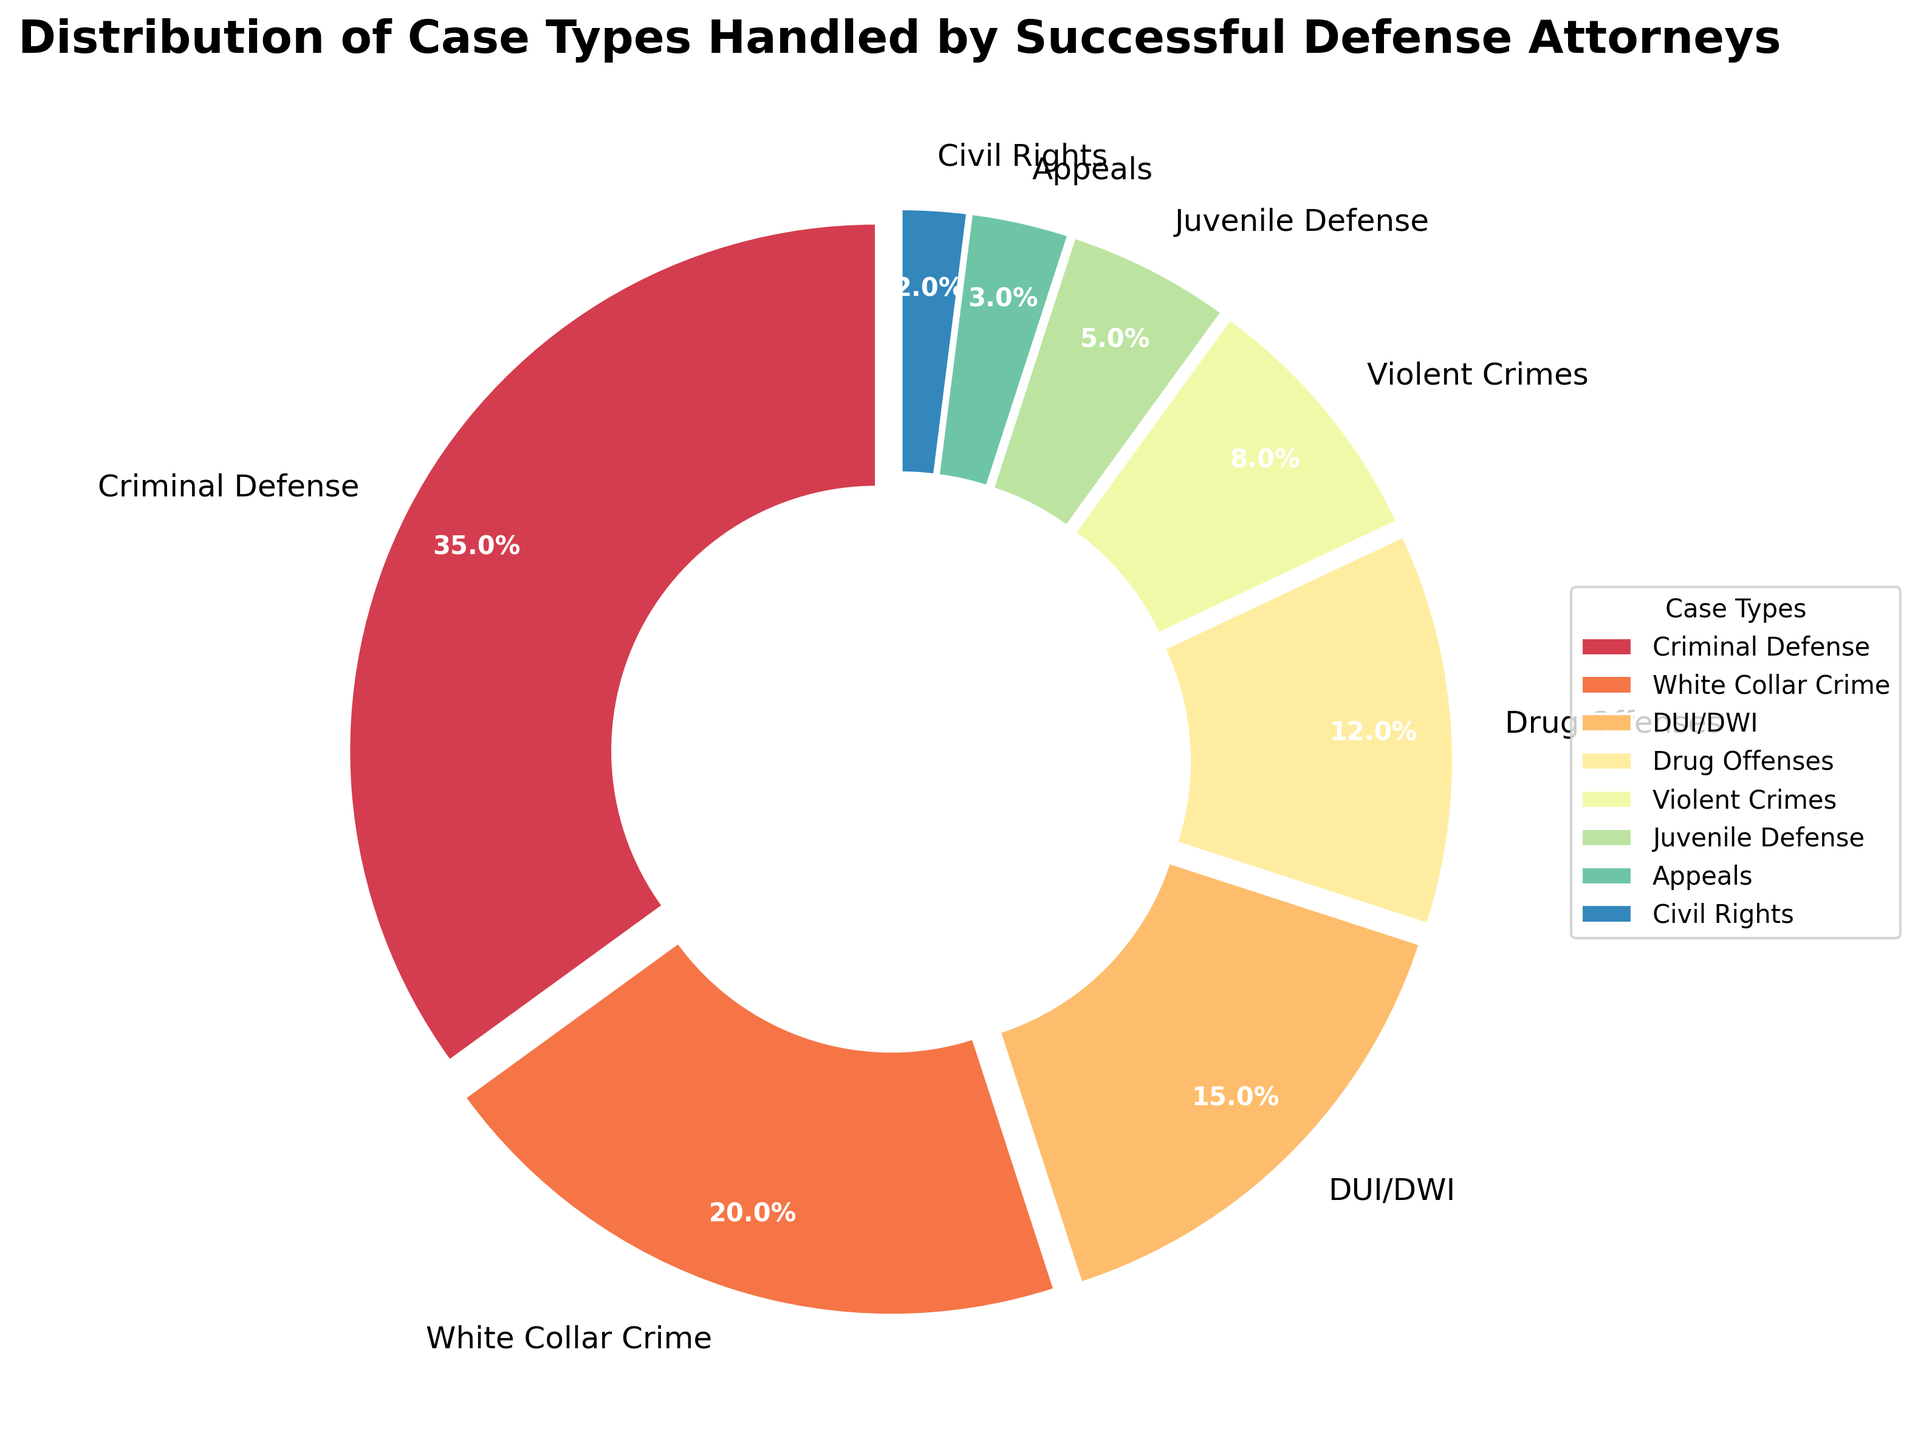Which case type is handled the most by successful defense attorneys? Observing the pie chart, Criminal Defense has the largest slice in the distribution, making it the most handled case type.
Answer: Criminal Defense Which case type is handled the least by successful defense attorneys? The smallest slice in the pie chart corresponds to Civil Rights, indicating it is the least handled case type.
Answer: Civil Rights How many percentage points more are Criminal Defense cases than White Collar Crime cases? Criminal Defense handles 35%, whereas White Collar Crime handles 20%. The difference is 35% - 20% = 15%.
Answer: 15% What is the combined percentage of DUI/DWI and Drug Offenses cases? The percentage of DUI/DWI cases is 15%, and Drug Offenses cases are 12%. Adding these together gives 15% + 12% = 27%.
Answer: 27% Which case type is more common, Juvenile Defense or Violent Crimes? Observing the pie chart, Violent Crimes have a larger slice (8%) compared to Juvenile Defense (5%), indicating Violent Crimes are more common.
Answer: Violent Crimes What percentage of cases handled is made up of Violent Crimes and Juvenile Defense combined? The percentage for Violent Crimes is 8%, and for Juvenile Defense, it is 5%. The sum is 8% + 5% = 13%.
Answer: 13% Are Drug Offenses cases handled more than DUI/DWI cases, and by how much? Drug Offenses make up 12% of the cases, whereas DUI/DWI makes up 15%. Since 12% < 15%, Drug Offenses are handled less than DUI/DWI by 3 percentage points (15%-12%).
Answer: No, by 3 percentage points 